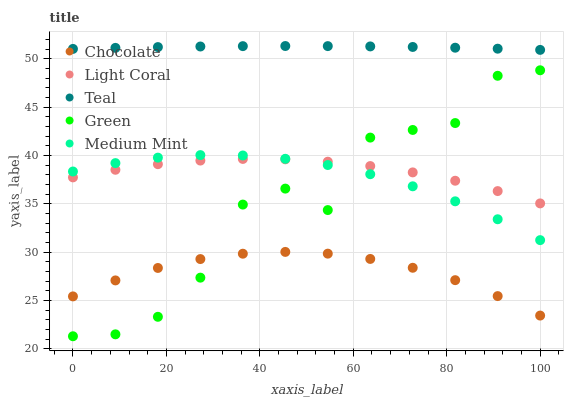Does Chocolate have the minimum area under the curve?
Answer yes or no. Yes. Does Teal have the maximum area under the curve?
Answer yes or no. Yes. Does Medium Mint have the minimum area under the curve?
Answer yes or no. No. Does Medium Mint have the maximum area under the curve?
Answer yes or no. No. Is Teal the smoothest?
Answer yes or no. Yes. Is Green the roughest?
Answer yes or no. Yes. Is Medium Mint the smoothest?
Answer yes or no. No. Is Medium Mint the roughest?
Answer yes or no. No. Does Green have the lowest value?
Answer yes or no. Yes. Does Medium Mint have the lowest value?
Answer yes or no. No. Does Teal have the highest value?
Answer yes or no. Yes. Does Medium Mint have the highest value?
Answer yes or no. No. Is Medium Mint less than Teal?
Answer yes or no. Yes. Is Teal greater than Light Coral?
Answer yes or no. Yes. Does Green intersect Chocolate?
Answer yes or no. Yes. Is Green less than Chocolate?
Answer yes or no. No. Is Green greater than Chocolate?
Answer yes or no. No. Does Medium Mint intersect Teal?
Answer yes or no. No. 